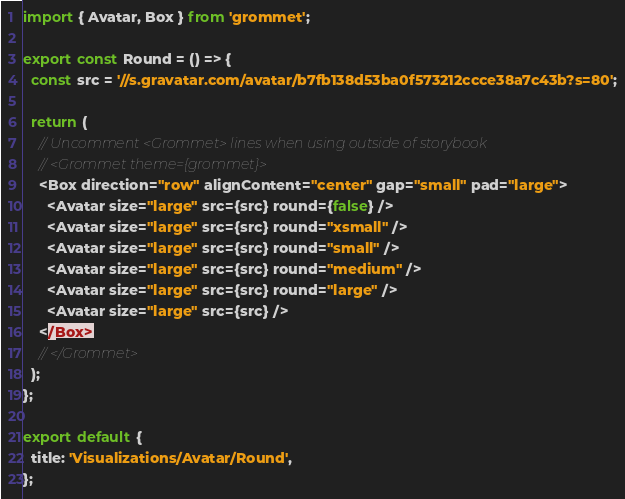<code> <loc_0><loc_0><loc_500><loc_500><_JavaScript_>
import { Avatar, Box } from 'grommet';

export const Round = () => {
  const src = '//s.gravatar.com/avatar/b7fb138d53ba0f573212ccce38a7c43b?s=80';

  return (
    // Uncomment <Grommet> lines when using outside of storybook
    // <Grommet theme={grommet}>
    <Box direction="row" alignContent="center" gap="small" pad="large">
      <Avatar size="large" src={src} round={false} />
      <Avatar size="large" src={src} round="xsmall" />
      <Avatar size="large" src={src} round="small" />
      <Avatar size="large" src={src} round="medium" />
      <Avatar size="large" src={src} round="large" />
      <Avatar size="large" src={src} />
    </Box>
    // </Grommet>
  );
};

export default {
  title: 'Visualizations/Avatar/Round',
};
</code> 